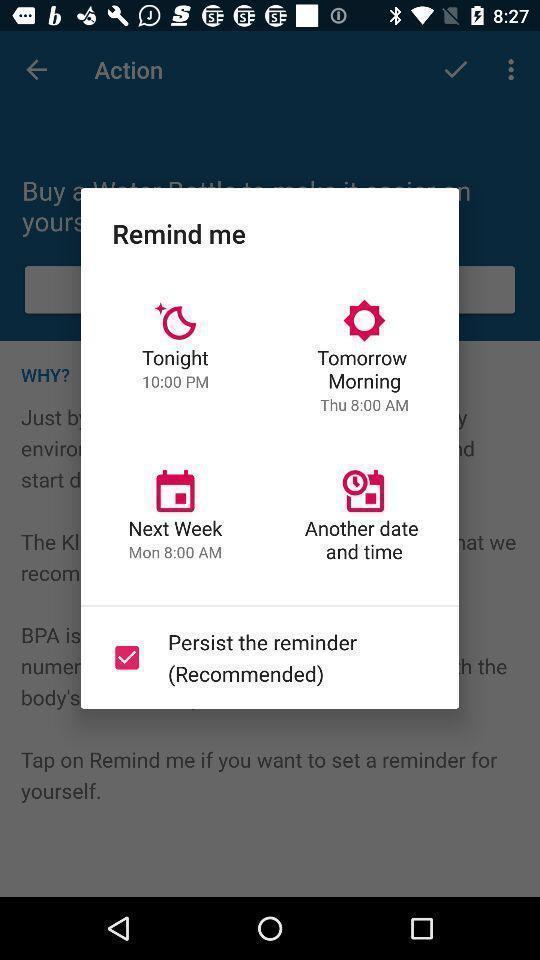Tell me about the visual elements in this screen capture. Pop-up showing schedule reminder in the app. 